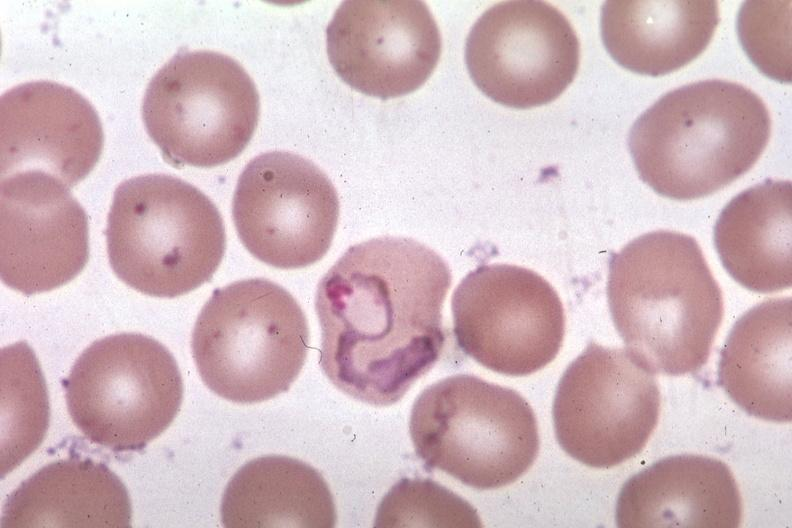does this image show oil wrights excellent tropho?
Answer the question using a single word or phrase. Yes 